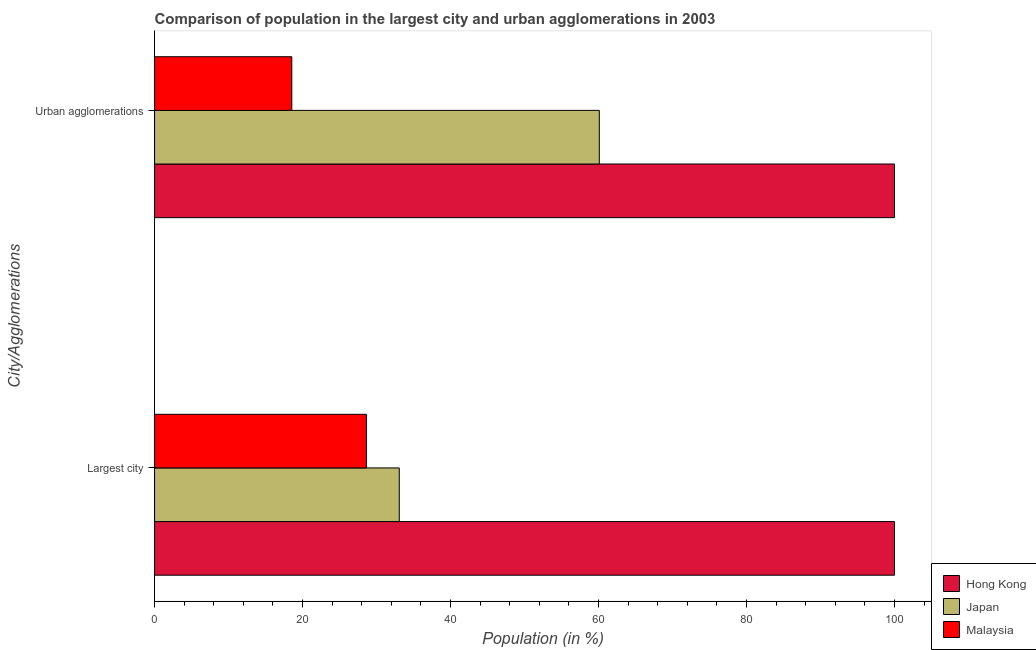How many different coloured bars are there?
Provide a short and direct response. 3. How many groups of bars are there?
Give a very brief answer. 2. How many bars are there on the 2nd tick from the top?
Make the answer very short. 3. How many bars are there on the 2nd tick from the bottom?
Your answer should be very brief. 3. What is the label of the 1st group of bars from the top?
Keep it short and to the point. Urban agglomerations. What is the population in urban agglomerations in Hong Kong?
Provide a short and direct response. 100. Across all countries, what is the maximum population in urban agglomerations?
Your answer should be very brief. 100. Across all countries, what is the minimum population in urban agglomerations?
Make the answer very short. 18.55. In which country was the population in the largest city maximum?
Keep it short and to the point. Hong Kong. In which country was the population in the largest city minimum?
Provide a short and direct response. Malaysia. What is the total population in urban agglomerations in the graph?
Provide a short and direct response. 178.65. What is the difference between the population in urban agglomerations in Hong Kong and that in Malaysia?
Your response must be concise. 81.45. What is the difference between the population in the largest city in Malaysia and the population in urban agglomerations in Hong Kong?
Ensure brevity in your answer.  -71.37. What is the average population in urban agglomerations per country?
Ensure brevity in your answer.  59.55. In how many countries, is the population in the largest city greater than 92 %?
Provide a short and direct response. 1. What is the ratio of the population in urban agglomerations in Hong Kong to that in Japan?
Ensure brevity in your answer.  1.66. Is the population in urban agglomerations in Malaysia less than that in Japan?
Make the answer very short. Yes. In how many countries, is the population in urban agglomerations greater than the average population in urban agglomerations taken over all countries?
Offer a very short reply. 2. What does the 1st bar from the top in Urban agglomerations represents?
Provide a succinct answer. Malaysia. How many bars are there?
Offer a very short reply. 6. Are all the bars in the graph horizontal?
Give a very brief answer. Yes. How many countries are there in the graph?
Provide a short and direct response. 3. What is the difference between two consecutive major ticks on the X-axis?
Offer a terse response. 20. Are the values on the major ticks of X-axis written in scientific E-notation?
Your answer should be very brief. No. Where does the legend appear in the graph?
Make the answer very short. Bottom right. What is the title of the graph?
Make the answer very short. Comparison of population in the largest city and urban agglomerations in 2003. Does "Nigeria" appear as one of the legend labels in the graph?
Offer a terse response. No. What is the label or title of the Y-axis?
Make the answer very short. City/Agglomerations. What is the Population (in %) in Japan in Largest city?
Ensure brevity in your answer.  33.07. What is the Population (in %) in Malaysia in Largest city?
Ensure brevity in your answer.  28.63. What is the Population (in %) of Hong Kong in Urban agglomerations?
Offer a terse response. 100. What is the Population (in %) in Japan in Urban agglomerations?
Ensure brevity in your answer.  60.11. What is the Population (in %) of Malaysia in Urban agglomerations?
Offer a terse response. 18.55. Across all City/Agglomerations, what is the maximum Population (in %) of Hong Kong?
Offer a terse response. 100. Across all City/Agglomerations, what is the maximum Population (in %) of Japan?
Give a very brief answer. 60.11. Across all City/Agglomerations, what is the maximum Population (in %) in Malaysia?
Ensure brevity in your answer.  28.63. Across all City/Agglomerations, what is the minimum Population (in %) in Hong Kong?
Keep it short and to the point. 100. Across all City/Agglomerations, what is the minimum Population (in %) in Japan?
Your answer should be compact. 33.07. Across all City/Agglomerations, what is the minimum Population (in %) in Malaysia?
Your answer should be compact. 18.55. What is the total Population (in %) in Japan in the graph?
Make the answer very short. 93.18. What is the total Population (in %) of Malaysia in the graph?
Give a very brief answer. 47.18. What is the difference between the Population (in %) of Japan in Largest city and that in Urban agglomerations?
Make the answer very short. -27.04. What is the difference between the Population (in %) in Malaysia in Largest city and that in Urban agglomerations?
Your answer should be very brief. 10.08. What is the difference between the Population (in %) in Hong Kong in Largest city and the Population (in %) in Japan in Urban agglomerations?
Make the answer very short. 39.89. What is the difference between the Population (in %) of Hong Kong in Largest city and the Population (in %) of Malaysia in Urban agglomerations?
Give a very brief answer. 81.45. What is the difference between the Population (in %) in Japan in Largest city and the Population (in %) in Malaysia in Urban agglomerations?
Your answer should be very brief. 14.53. What is the average Population (in %) in Japan per City/Agglomerations?
Offer a terse response. 46.59. What is the average Population (in %) of Malaysia per City/Agglomerations?
Make the answer very short. 23.59. What is the difference between the Population (in %) of Hong Kong and Population (in %) of Japan in Largest city?
Ensure brevity in your answer.  66.93. What is the difference between the Population (in %) of Hong Kong and Population (in %) of Malaysia in Largest city?
Your answer should be very brief. 71.37. What is the difference between the Population (in %) in Japan and Population (in %) in Malaysia in Largest city?
Your answer should be very brief. 4.44. What is the difference between the Population (in %) in Hong Kong and Population (in %) in Japan in Urban agglomerations?
Your answer should be very brief. 39.89. What is the difference between the Population (in %) in Hong Kong and Population (in %) in Malaysia in Urban agglomerations?
Your response must be concise. 81.45. What is the difference between the Population (in %) of Japan and Population (in %) of Malaysia in Urban agglomerations?
Make the answer very short. 41.56. What is the ratio of the Population (in %) of Hong Kong in Largest city to that in Urban agglomerations?
Keep it short and to the point. 1. What is the ratio of the Population (in %) in Japan in Largest city to that in Urban agglomerations?
Keep it short and to the point. 0.55. What is the ratio of the Population (in %) of Malaysia in Largest city to that in Urban agglomerations?
Ensure brevity in your answer.  1.54. What is the difference between the highest and the second highest Population (in %) in Japan?
Your response must be concise. 27.04. What is the difference between the highest and the second highest Population (in %) in Malaysia?
Your answer should be very brief. 10.08. What is the difference between the highest and the lowest Population (in %) in Hong Kong?
Keep it short and to the point. 0. What is the difference between the highest and the lowest Population (in %) of Japan?
Your answer should be compact. 27.04. What is the difference between the highest and the lowest Population (in %) in Malaysia?
Your response must be concise. 10.08. 